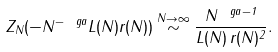<formula> <loc_0><loc_0><loc_500><loc_500>Z _ { N } ( - N ^ { - \ g a } L ( N ) r ( N ) ) \stackrel { N \to \infty } \sim \frac { N ^ { \ g a - 1 } } { L ( N ) \, r ( N ) ^ { 2 } } .</formula> 